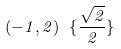Convert formula to latex. <formula><loc_0><loc_0><loc_500><loc_500>( - 1 , 2 ) \ \{ \frac { \sqrt { 2 } } { 2 } \}</formula> 